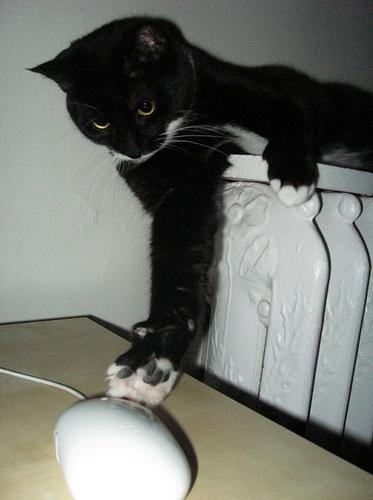What is the cat playing with?
Quick response, please. Mouse. Will this cat attack?
Write a very short answer. Yes. Is this mouse alive?
Be succinct. No. 